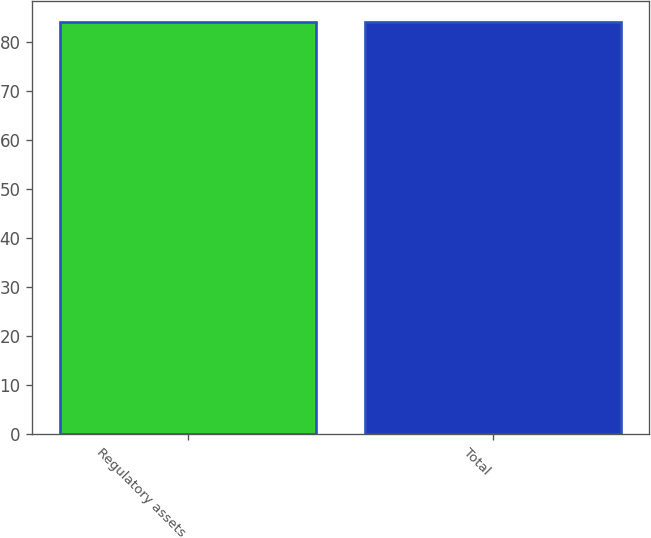<chart> <loc_0><loc_0><loc_500><loc_500><bar_chart><fcel>Regulatory assets<fcel>Total<nl><fcel>84<fcel>84.1<nl></chart> 